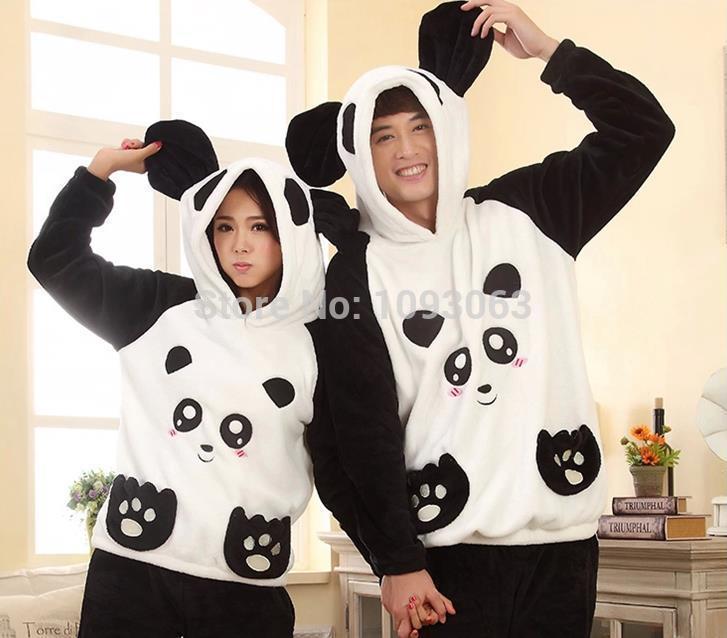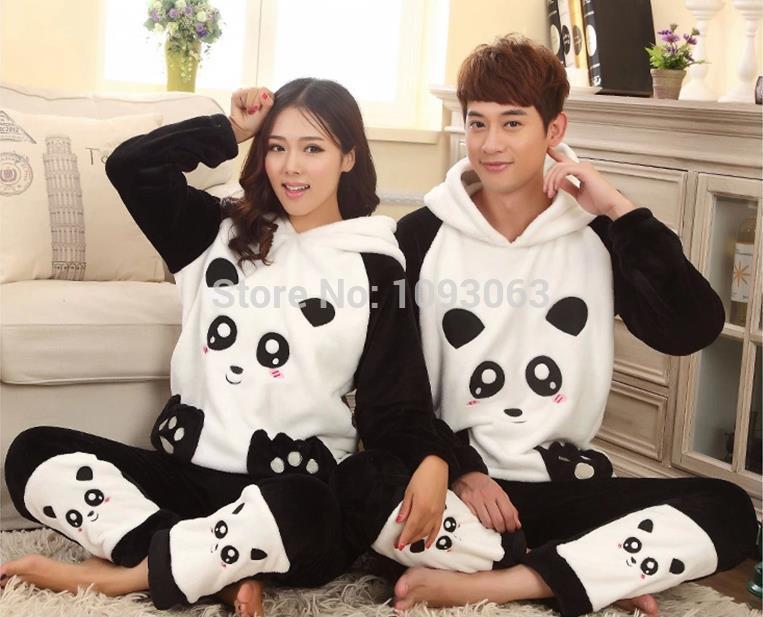The first image is the image on the left, the second image is the image on the right. Analyze the images presented: Is the assertion "In one of the image the woman has her hood pulled up." valid? Answer yes or no. Yes. The first image is the image on the left, the second image is the image on the right. Given the left and right images, does the statement "Each image contains a man and a woman wearing matching clothing." hold true? Answer yes or no. Yes. 